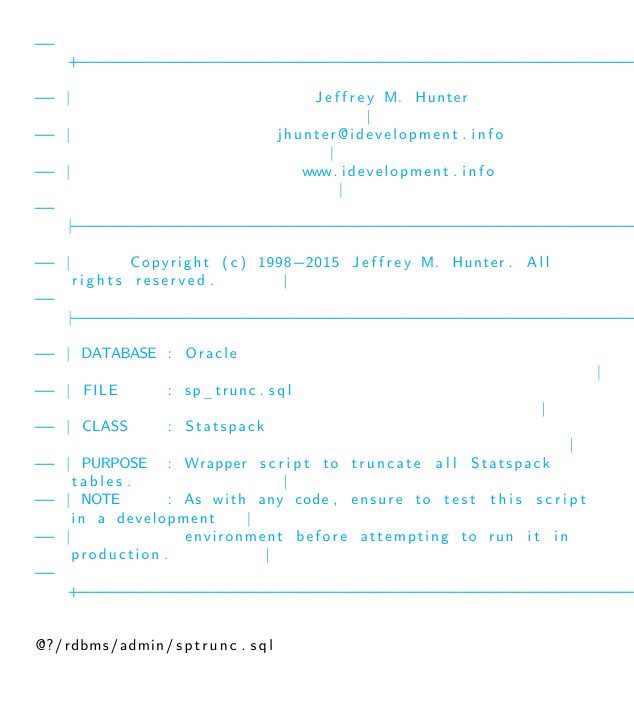Convert code to text. <code><loc_0><loc_0><loc_500><loc_500><_SQL_>-- +----------------------------------------------------------------------------+
-- |                          Jeffrey M. Hunter                                 |
-- |                      jhunter@idevelopment.info                             |
-- |                         www.idevelopment.info                              |
-- |----------------------------------------------------------------------------|
-- |      Copyright (c) 1998-2015 Jeffrey M. Hunter. All rights reserved.       |
-- |----------------------------------------------------------------------------|
-- | DATABASE : Oracle                                                          |
-- | FILE     : sp_trunc.sql                                                    |
-- | CLASS    : Statspack                                                       |
-- | PURPOSE  : Wrapper script to truncate all Statspack tables.                |
-- | NOTE     : As with any code, ensure to test this script in a development   |
-- |            environment before attempting to run it in production.          |
-- +----------------------------------------------------------------------------+

@?/rdbms/admin/sptrunc.sql

</code> 